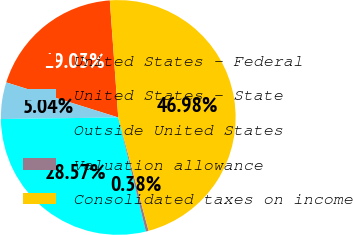Convert chart to OTSL. <chart><loc_0><loc_0><loc_500><loc_500><pie_chart><fcel>United States - Federal<fcel>United States - State<fcel>Outside United States<fcel>Valuation allowance<fcel>Consolidated taxes on income<nl><fcel>19.03%<fcel>5.04%<fcel>28.57%<fcel>0.38%<fcel>46.98%<nl></chart> 